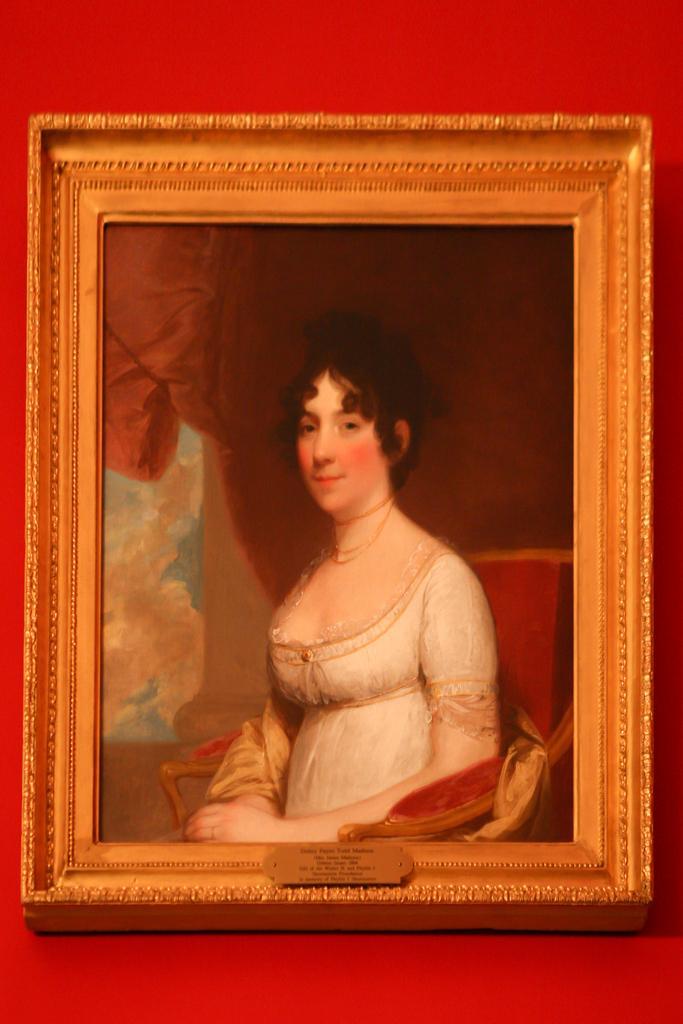Can you describe this image briefly? In this image we can see a painting of a woman which is attached to the red color wall. 